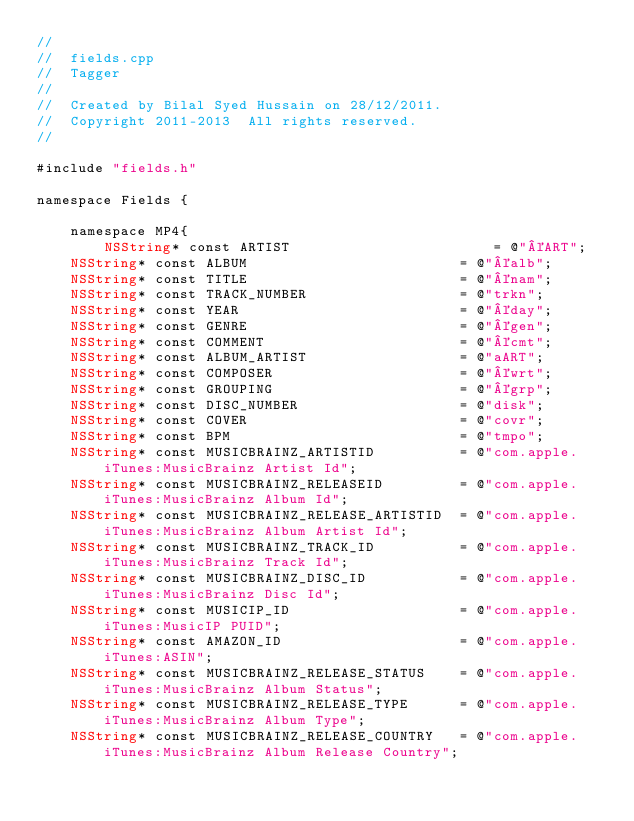<code> <loc_0><loc_0><loc_500><loc_500><_ObjectiveC_>//
//  fields.cpp
//  Tagger
//
//  Created by Bilal Syed Hussain on 28/12/2011.
//  Copyright 2011-2013  All rights reserved.
//

#include "fields.h"

namespace Fields {
    
    namespace MP4{
        NSString* const ARTIST                        = @"©ART";
		NSString* const ALBUM                         = @"©alb";
		NSString* const TITLE                         = @"©nam";
		NSString* const TRACK_NUMBER                  = @"trkn";
		NSString* const YEAR                          = @"©day";
		NSString* const GENRE                         = @"©gen";
		NSString* const COMMENT                       = @"©cmt";
		NSString* const ALBUM_ARTIST                  = @"aART";
		NSString* const COMPOSER                      = @"©wrt";
		NSString* const GROUPING                      = @"©grp";
		NSString* const DISC_NUMBER                   = @"disk";
		NSString* const COVER                         = @"covr";
		NSString* const BPM                           = @"tmpo";
		NSString* const MUSICBRAINZ_ARTISTID          = @"com.apple.iTunes:MusicBrainz Artist Id";
		NSString* const MUSICBRAINZ_RELEASEID         = @"com.apple.iTunes:MusicBrainz Album Id";
		NSString* const MUSICBRAINZ_RELEASE_ARTISTID  = @"com.apple.iTunes:MusicBrainz Album Artist Id";
		NSString* const MUSICBRAINZ_TRACK_ID          = @"com.apple.iTunes:MusicBrainz Track Id";
		NSString* const MUSICBRAINZ_DISC_ID           = @"com.apple.iTunes:MusicBrainz Disc Id";
		NSString* const MUSICIP_ID                    = @"com.apple.iTunes:MusicIP PUID";
		NSString* const AMAZON_ID                     = @"com.apple.iTunes:ASIN";
		NSString* const MUSICBRAINZ_RELEASE_STATUS    = @"com.apple.iTunes:MusicBrainz Album Status";
		NSString* const MUSICBRAINZ_RELEASE_TYPE      = @"com.apple.iTunes:MusicBrainz Album Type";
		NSString* const MUSICBRAINZ_RELEASE_COUNTRY   = @"com.apple.iTunes:MusicBrainz Album Release Country";</code> 